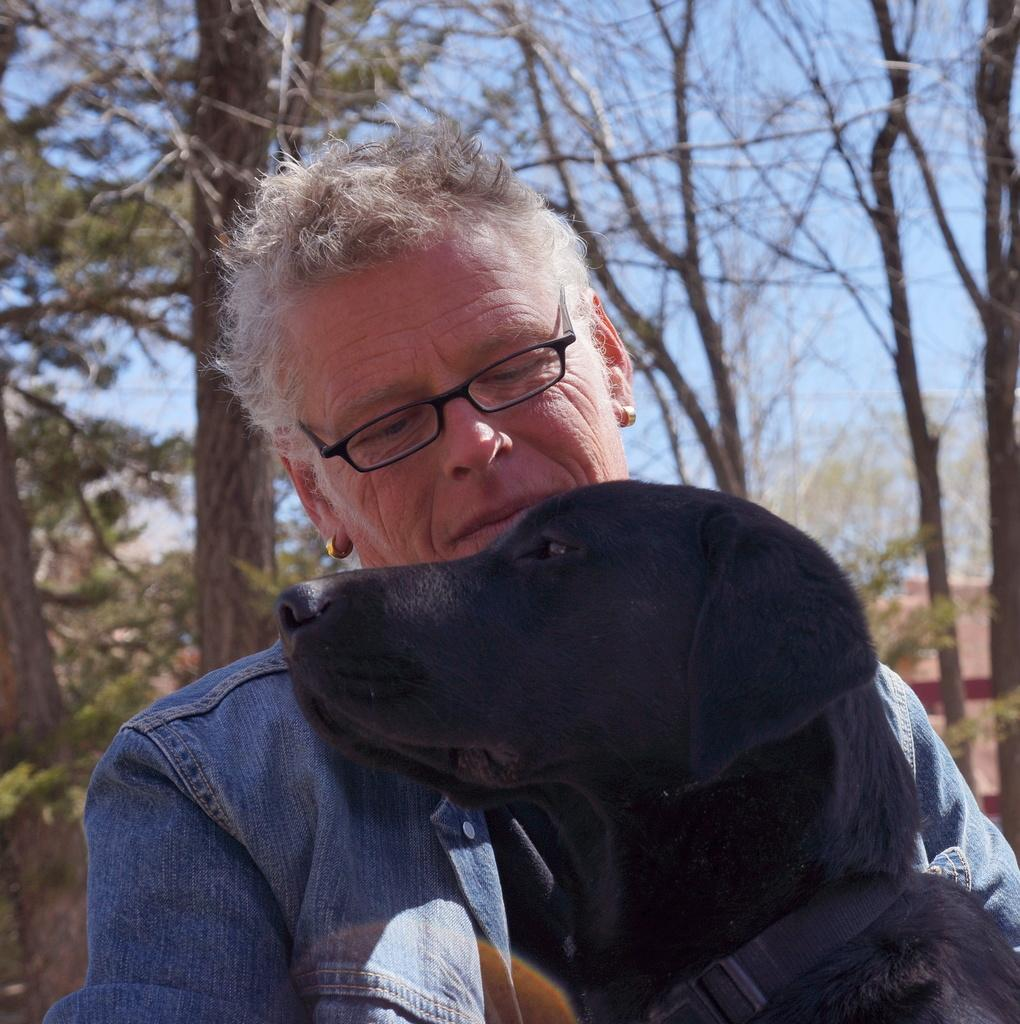Who is the main subject in the image? There is an old man in the image. What is the old man holding in the image? The old man is holding a dog. What is the color of the dog? The dog is black in color. What type of natural environment is visible in the image? There are trees visible in the image. What type of structure can be seen in the image? There is a building in the image. What is visible at the top of the image? The sky is visible in the image. What type of quilt is the old man using to cover the picture in the image? There is no quilt or picture present in the image. What type of lipstick is the old man wearing in the image? The old man is not wearing any lipstick in the image. 